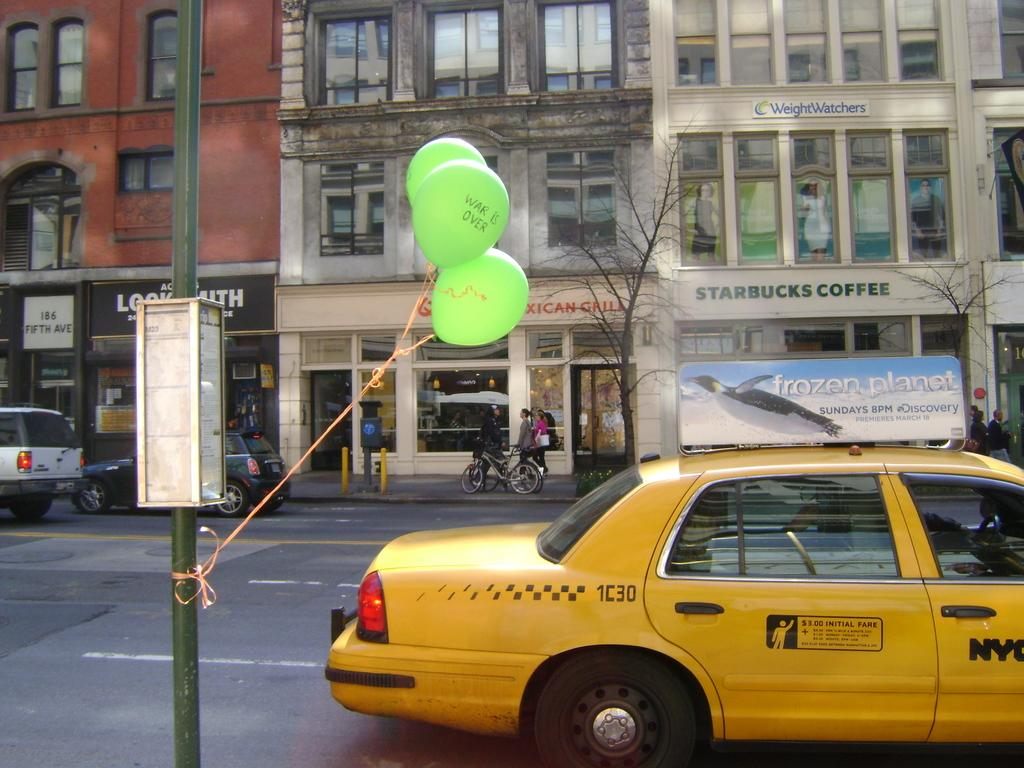<image>
Create a compact narrative representing the image presented. Green balloons that say war is over are tied to a telephone pole and flying in the air by the street. 